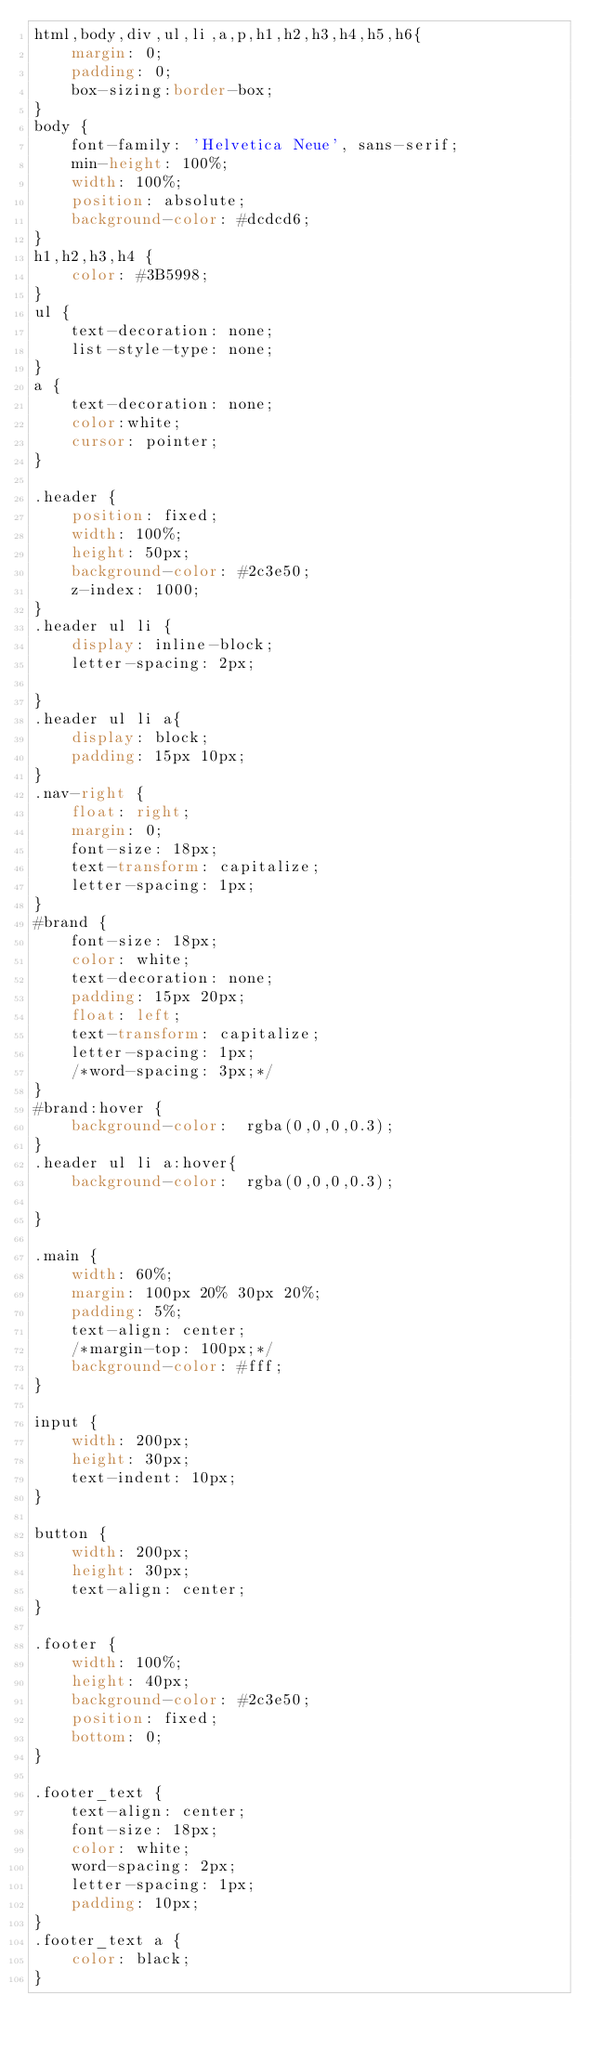Convert code to text. <code><loc_0><loc_0><loc_500><loc_500><_CSS_>html,body,div,ul,li,a,p,h1,h2,h3,h4,h5,h6{
	margin: 0;
	padding: 0;
	box-sizing:border-box;
}
body {
	font-family: 'Helvetica Neue', sans-serif;
	min-height: 100%;
	width: 100%;
	position: absolute;
	background-color: #dcdcd6;
}
h1,h2,h3,h4 {
	color: #3B5998;
}
ul {
	text-decoration: none;
	list-style-type: none;
}
a {
	text-decoration: none;
	color:white;
	cursor: pointer;
}

.header {
	position: fixed;
	width: 100%;
	height: 50px;
	background-color: #2c3e50;
	z-index: 1000;
}
.header ul li {
	display: inline-block;
	letter-spacing: 2px;
	
}
.header ul li a{
	display: block;
	padding: 15px 10px;
}
.nav-right {
	float: right;
	margin: 0;
	font-size: 18px;
	text-transform: capitalize;
	letter-spacing: 1px;
}
#brand {
	font-size: 18px;
	color: white;
	text-decoration: none;
	padding: 15px 20px;
	float: left;
	text-transform: capitalize;
	letter-spacing: 1px;
	/*word-spacing: 3px;*/
}
#brand:hover {
	background-color:  rgba(0,0,0,0.3);
}
.header ul li a:hover{
	background-color:  rgba(0,0,0,0.3);

}

.main {
	width: 60%;
	margin: 100px 20% 30px 20%;
	padding: 5%;
	text-align: center;
	/*margin-top: 100px;*/
	background-color: #fff;
}

input {
	width: 200px;
	height: 30px;
	text-indent: 10px;
}

button {
	width: 200px;
	height: 30px;
	text-align: center;
}

.footer {
	width: 100%;
	height: 40px;
	background-color: #2c3e50;
	position: fixed;
	bottom: 0;
}

.footer_text {
	text-align: center;
	font-size: 18px;
	color: white;
	word-spacing: 2px;
	letter-spacing: 1px;
	padding: 10px;		
}
.footer_text a {
	color: black;
}</code> 